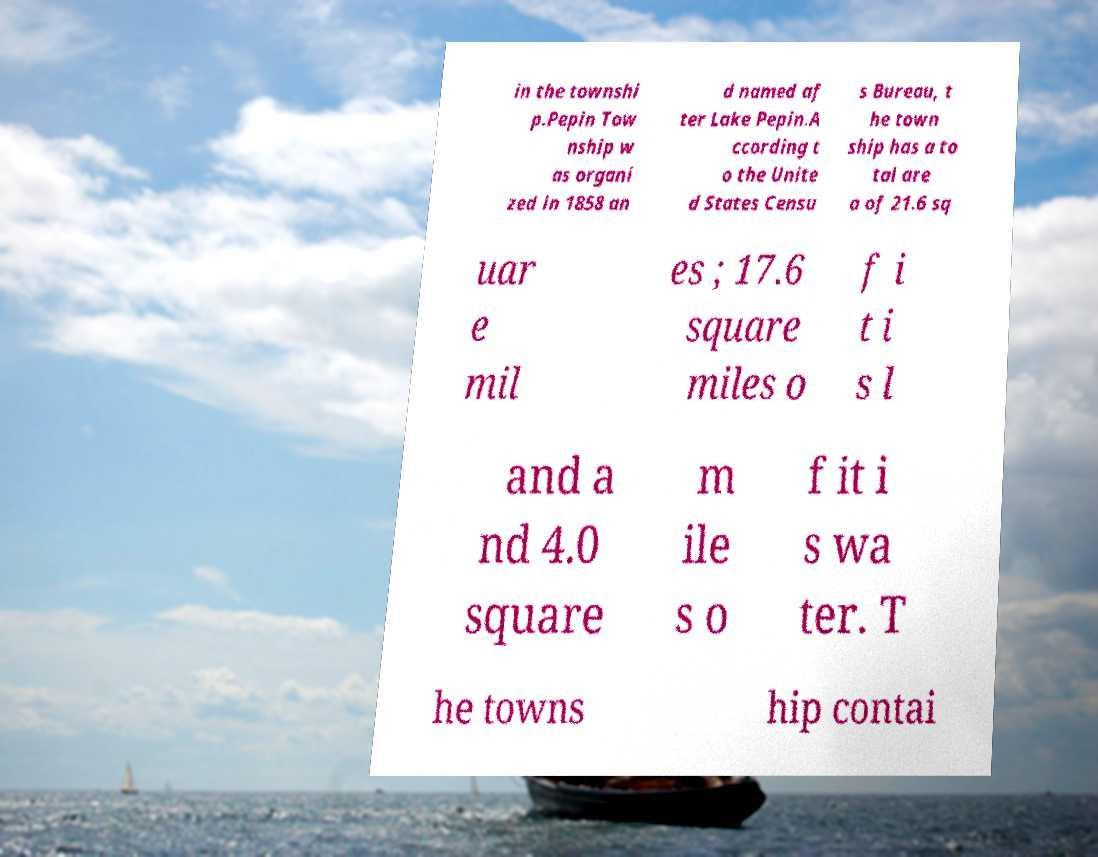Could you extract and type out the text from this image? in the townshi p.Pepin Tow nship w as organi zed in 1858 an d named af ter Lake Pepin.A ccording t o the Unite d States Censu s Bureau, t he town ship has a to tal are a of 21.6 sq uar e mil es ; 17.6 square miles o f i t i s l and a nd 4.0 square m ile s o f it i s wa ter. T he towns hip contai 